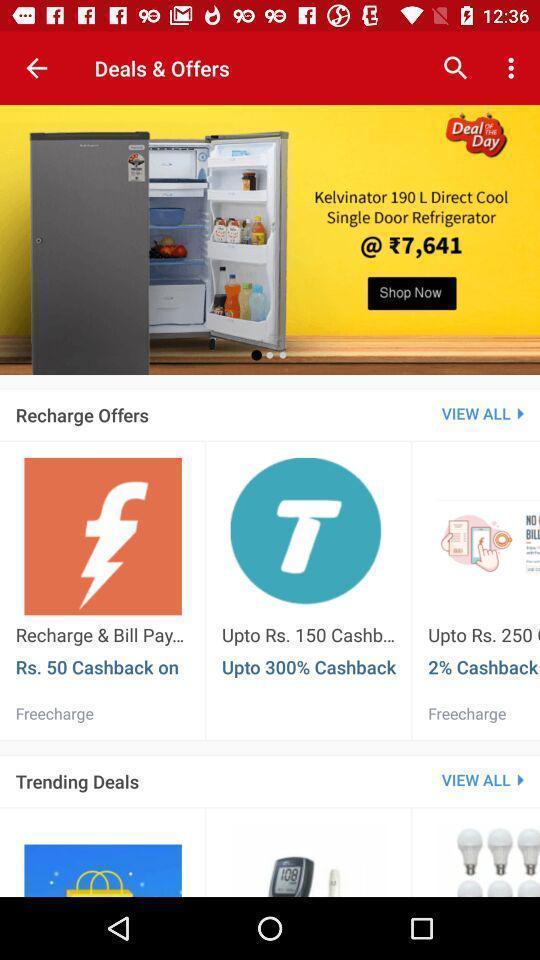Describe this image in words. Screen displaying deals and offers. 